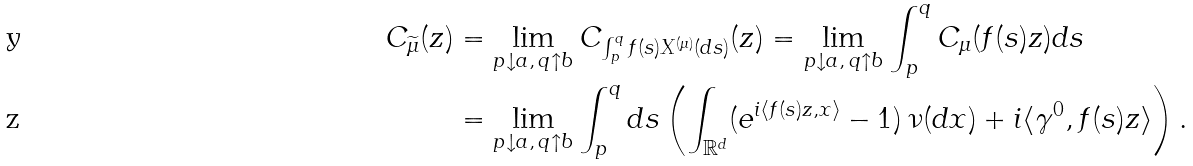<formula> <loc_0><loc_0><loc_500><loc_500>C _ { \widetilde { \mu } } ( z ) & = \lim _ { p \downarrow a , \, q \uparrow b } C _ { \int _ { p } ^ { q } f ( s ) X ^ { ( \mu ) } ( d s ) } ( z ) = \lim _ { p \downarrow a , \, q \uparrow b } \int _ { p } ^ { q } C _ { \mu } ( f ( s ) z ) d s \\ & = \lim _ { p \downarrow a , \, q \uparrow b } \int _ { p } ^ { q } d s \left ( \int _ { \mathbb { R } ^ { d } } ( e ^ { i \langle f ( s ) z , x \rangle } - 1 ) \, \nu ( d x ) + i \langle \gamma ^ { 0 } , f ( s ) z \rangle \right ) .</formula> 